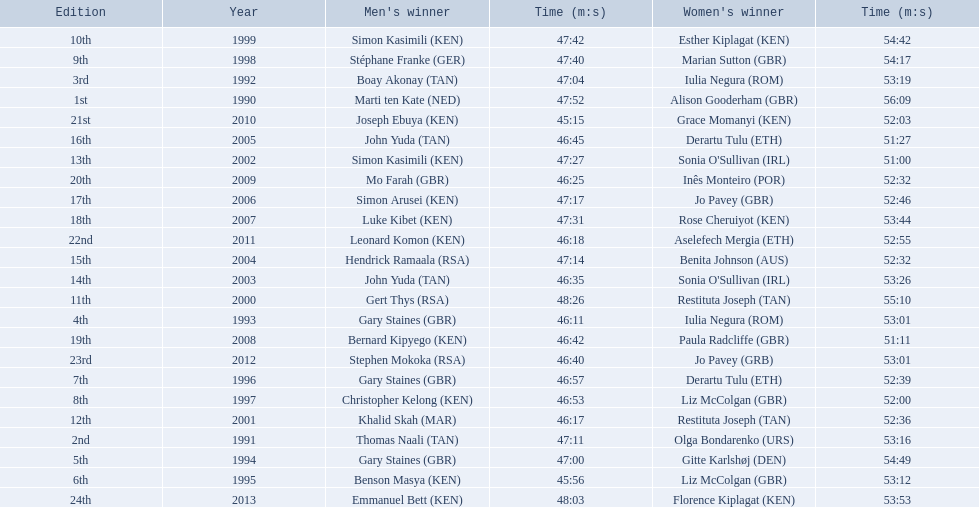What place did sonia o'sullivan finish in 2003? 14th. How long did it take her to finish? 53:26. 